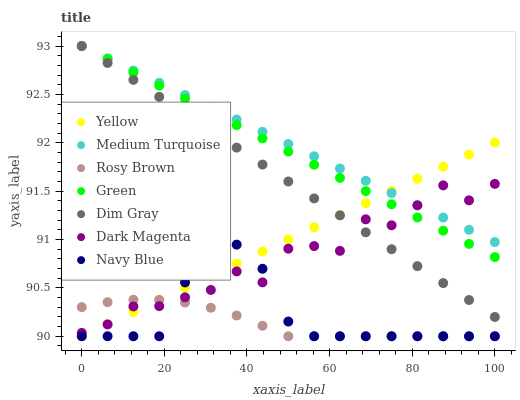Does Rosy Brown have the minimum area under the curve?
Answer yes or no. Yes. Does Medium Turquoise have the maximum area under the curve?
Answer yes or no. Yes. Does Dark Magenta have the minimum area under the curve?
Answer yes or no. No. Does Dark Magenta have the maximum area under the curve?
Answer yes or no. No. Is Green the smoothest?
Answer yes or no. Yes. Is Dark Magenta the roughest?
Answer yes or no. Yes. Is Navy Blue the smoothest?
Answer yes or no. No. Is Navy Blue the roughest?
Answer yes or no. No. Does Navy Blue have the lowest value?
Answer yes or no. Yes. Does Dark Magenta have the lowest value?
Answer yes or no. No. Does Medium Turquoise have the highest value?
Answer yes or no. Yes. Does Dark Magenta have the highest value?
Answer yes or no. No. Is Navy Blue less than Dim Gray?
Answer yes or no. Yes. Is Dim Gray greater than Navy Blue?
Answer yes or no. Yes. Does Navy Blue intersect Yellow?
Answer yes or no. Yes. Is Navy Blue less than Yellow?
Answer yes or no. No. Is Navy Blue greater than Yellow?
Answer yes or no. No. Does Navy Blue intersect Dim Gray?
Answer yes or no. No. 